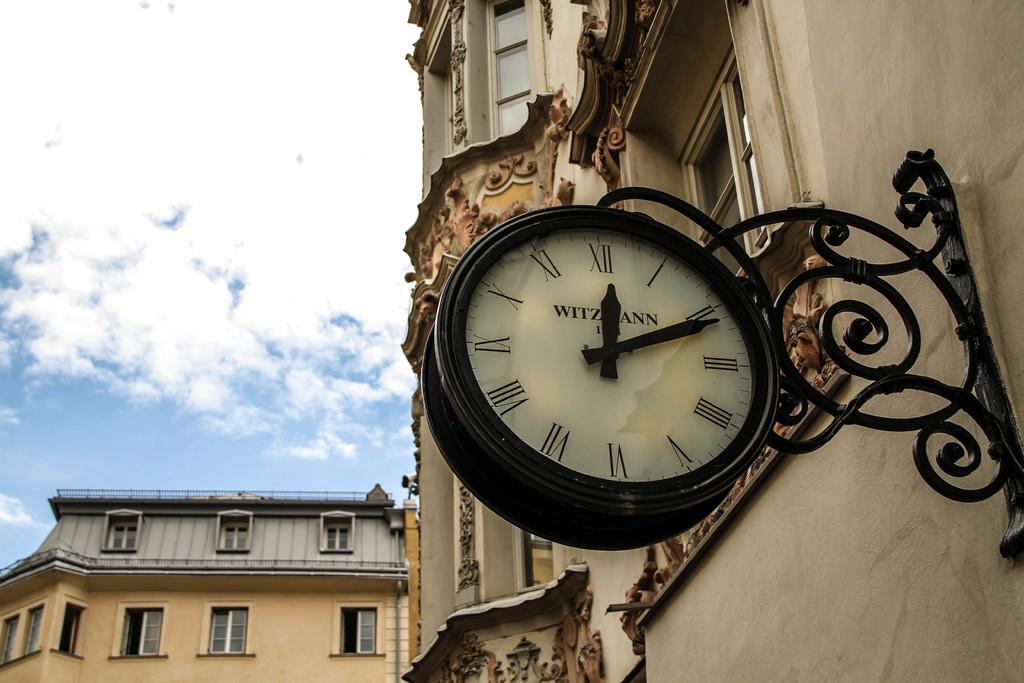Is that the clock makers name behind the hands?
Ensure brevity in your answer.  Yes. What time is it on the clock?
Provide a succinct answer. 12:11. 